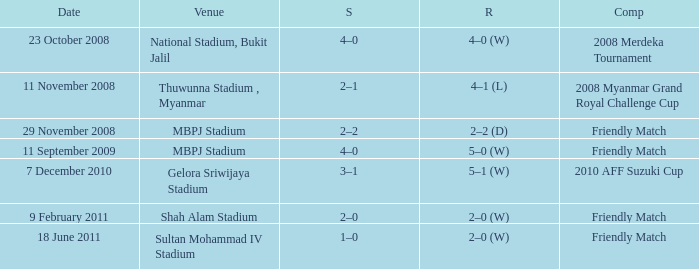What Competition had a Score of 2–0? Friendly Match. Can you parse all the data within this table? {'header': ['Date', 'Venue', 'S', 'R', 'Comp'], 'rows': [['23 October 2008', 'National Stadium, Bukit Jalil', '4–0', '4–0 (W)', '2008 Merdeka Tournament'], ['11 November 2008', 'Thuwunna Stadium , Myanmar', '2–1', '4–1 (L)', '2008 Myanmar Grand Royal Challenge Cup'], ['29 November 2008', 'MBPJ Stadium', '2–2', '2–2 (D)', 'Friendly Match'], ['11 September 2009', 'MBPJ Stadium', '4–0', '5–0 (W)', 'Friendly Match'], ['7 December 2010', 'Gelora Sriwijaya Stadium', '3–1', '5–1 (W)', '2010 AFF Suzuki Cup'], ['9 February 2011', 'Shah Alam Stadium', '2–0', '2–0 (W)', 'Friendly Match'], ['18 June 2011', 'Sultan Mohammad IV Stadium', '1–0', '2–0 (W)', 'Friendly Match']]} 